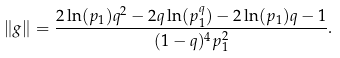<formula> <loc_0><loc_0><loc_500><loc_500>\| g \| = \frac { 2 \ln ( p _ { 1 } ) q ^ { 2 } - 2 q \ln ( p _ { 1 } ^ { q } ) - 2 \ln ( p _ { 1 } ) q - 1 } { ( 1 - q ) ^ { 4 } p _ { 1 } ^ { 2 } } .</formula> 